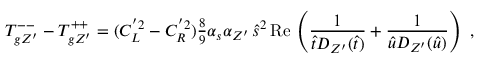<formula> <loc_0><loc_0><loc_500><loc_500>T _ { g Z ^ { \prime } } ^ { - - } - T _ { g Z ^ { \prime } } ^ { + + } = ( C _ { L } ^ { ^ { \prime } 2 } - C _ { R } ^ { ^ { \prime } 2 } ) { \frac { 8 } { 9 } } \alpha _ { s } \alpha _ { Z ^ { \prime } } \, \widehat { s } ^ { 2 } \, R e \, \left ( { \frac { 1 } { \widehat { t } D _ { Z ^ { \prime } } ( \widehat { t } ) } } + { \frac { 1 } { \widehat { u } D _ { Z ^ { \prime } } ( \widehat { u } ) } } \right ) \ ,</formula> 